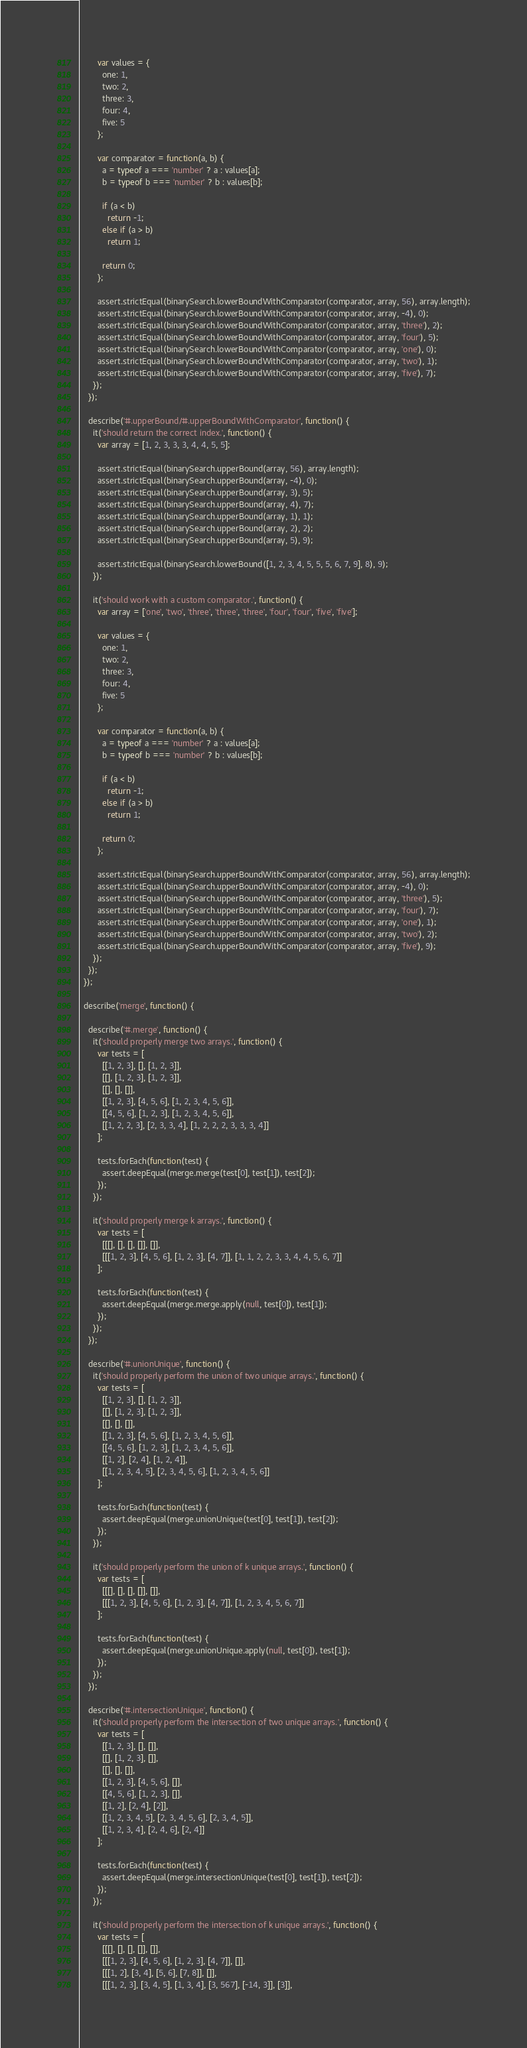<code> <loc_0><loc_0><loc_500><loc_500><_JavaScript_>
        var values = {
          one: 1,
          two: 2,
          three: 3,
          four: 4,
          five: 5
        };

        var comparator = function(a, b) {
          a = typeof a === 'number' ? a : values[a];
          b = typeof b === 'number' ? b : values[b];

          if (a < b)
            return -1;
          else if (a > b)
            return 1;

          return 0;
        };

        assert.strictEqual(binarySearch.lowerBoundWithComparator(comparator, array, 56), array.length);
        assert.strictEqual(binarySearch.lowerBoundWithComparator(comparator, array, -4), 0);
        assert.strictEqual(binarySearch.lowerBoundWithComparator(comparator, array, 'three'), 2);
        assert.strictEqual(binarySearch.lowerBoundWithComparator(comparator, array, 'four'), 5);
        assert.strictEqual(binarySearch.lowerBoundWithComparator(comparator, array, 'one'), 0);
        assert.strictEqual(binarySearch.lowerBoundWithComparator(comparator, array, 'two'), 1);
        assert.strictEqual(binarySearch.lowerBoundWithComparator(comparator, array, 'five'), 7);
      });
    });

    describe('#.upperBound/#.upperBoundWithComparator', function() {
      it('should return the correct index.', function() {
        var array = [1, 2, 3, 3, 3, 4, 4, 5, 5];

        assert.strictEqual(binarySearch.upperBound(array, 56), array.length);
        assert.strictEqual(binarySearch.upperBound(array, -4), 0);
        assert.strictEqual(binarySearch.upperBound(array, 3), 5);
        assert.strictEqual(binarySearch.upperBound(array, 4), 7);
        assert.strictEqual(binarySearch.upperBound(array, 1), 1);
        assert.strictEqual(binarySearch.upperBound(array, 2), 2);
        assert.strictEqual(binarySearch.upperBound(array, 5), 9);

        assert.strictEqual(binarySearch.lowerBound([1, 2, 3, 4, 5, 5, 5, 6, 7, 9], 8), 9);
      });

      it('should work with a custom comparator.', function() {
        var array = ['one', 'two', 'three', 'three', 'three', 'four', 'four', 'five', 'five'];

        var values = {
          one: 1,
          two: 2,
          three: 3,
          four: 4,
          five: 5
        };

        var comparator = function(a, b) {
          a = typeof a === 'number' ? a : values[a];
          b = typeof b === 'number' ? b : values[b];

          if (a < b)
            return -1;
          else if (a > b)
            return 1;

          return 0;
        };

        assert.strictEqual(binarySearch.upperBoundWithComparator(comparator, array, 56), array.length);
        assert.strictEqual(binarySearch.upperBoundWithComparator(comparator, array, -4), 0);
        assert.strictEqual(binarySearch.upperBoundWithComparator(comparator, array, 'three'), 5);
        assert.strictEqual(binarySearch.upperBoundWithComparator(comparator, array, 'four'), 7);
        assert.strictEqual(binarySearch.upperBoundWithComparator(comparator, array, 'one'), 1);
        assert.strictEqual(binarySearch.upperBoundWithComparator(comparator, array, 'two'), 2);
        assert.strictEqual(binarySearch.upperBoundWithComparator(comparator, array, 'five'), 9);
      });
    });
  });

  describe('merge', function() {

    describe('#.merge', function() {
      it('should properly merge two arrays.', function() {
        var tests = [
          [[1, 2, 3], [], [1, 2, 3]],
          [[], [1, 2, 3], [1, 2, 3]],
          [[], [], []],
          [[1, 2, 3], [4, 5, 6], [1, 2, 3, 4, 5, 6]],
          [[4, 5, 6], [1, 2, 3], [1, 2, 3, 4, 5, 6]],
          [[1, 2, 2, 3], [2, 3, 3, 4], [1, 2, 2, 2, 3, 3, 3, 4]]
        ];

        tests.forEach(function(test) {
          assert.deepEqual(merge.merge(test[0], test[1]), test[2]);
        });
      });

      it('should properly merge k arrays.', function() {
        var tests = [
          [[[], [], [], []], []],
          [[[1, 2, 3], [4, 5, 6], [1, 2, 3], [4, 7]], [1, 1, 2, 2, 3, 3, 4, 4, 5, 6, 7]]
        ];

        tests.forEach(function(test) {
          assert.deepEqual(merge.merge.apply(null, test[0]), test[1]);
        });
      });
    });

    describe('#.unionUnique', function() {
      it('should properly perform the union of two unique arrays.', function() {
        var tests = [
          [[1, 2, 3], [], [1, 2, 3]],
          [[], [1, 2, 3], [1, 2, 3]],
          [[], [], []],
          [[1, 2, 3], [4, 5, 6], [1, 2, 3, 4, 5, 6]],
          [[4, 5, 6], [1, 2, 3], [1, 2, 3, 4, 5, 6]],
          [[1, 2], [2, 4], [1, 2, 4]],
          [[1, 2, 3, 4, 5], [2, 3, 4, 5, 6], [1, 2, 3, 4, 5, 6]]
        ];

        tests.forEach(function(test) {
          assert.deepEqual(merge.unionUnique(test[0], test[1]), test[2]);
        });
      });

      it('should properly perform the union of k unique arrays.', function() {
        var tests = [
          [[[], [], [], []], []],
          [[[1, 2, 3], [4, 5, 6], [1, 2, 3], [4, 7]], [1, 2, 3, 4, 5, 6, 7]]
        ];

        tests.forEach(function(test) {
          assert.deepEqual(merge.unionUnique.apply(null, test[0]), test[1]);
        });
      });
    });

    describe('#.intersectionUnique', function() {
      it('should properly perform the intersection of two unique arrays.', function() {
        var tests = [
          [[1, 2, 3], [], []],
          [[], [1, 2, 3], []],
          [[], [], []],
          [[1, 2, 3], [4, 5, 6], []],
          [[4, 5, 6], [1, 2, 3], []],
          [[1, 2], [2, 4], [2]],
          [[1, 2, 3, 4, 5], [2, 3, 4, 5, 6], [2, 3, 4, 5]],
          [[1, 2, 3, 4], [2, 4, 6], [2, 4]]
        ];

        tests.forEach(function(test) {
          assert.deepEqual(merge.intersectionUnique(test[0], test[1]), test[2]);
        });
      });

      it('should properly perform the intersection of k unique arrays.', function() {
        var tests = [
          [[[], [], [], []], []],
          [[[1, 2, 3], [4, 5, 6], [1, 2, 3], [4, 7]], []],
          [[[1, 2], [3, 4], [5, 6], [7, 8]], []],
          [[[1, 2, 3], [3, 4, 5], [1, 3, 4], [3, 567], [-14, 3]], [3]],</code> 